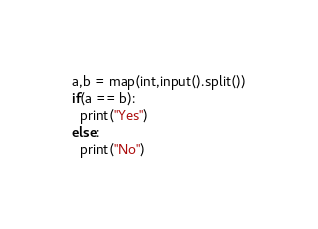Convert code to text. <code><loc_0><loc_0><loc_500><loc_500><_Python_>a,b = map(int,input().split())
if(a == b):
  print("Yes")
else:
  print("No")</code> 